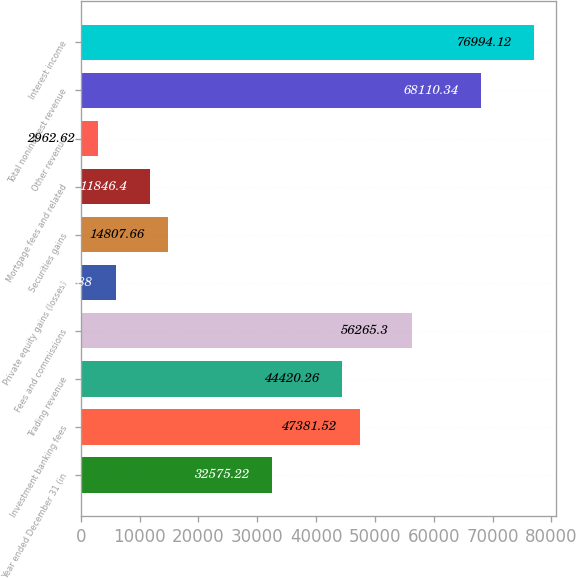Convert chart. <chart><loc_0><loc_0><loc_500><loc_500><bar_chart><fcel>Year ended December 31 (in<fcel>Investment banking fees<fcel>Trading revenue<fcel>Fees and commissions<fcel>Private equity gains (losses)<fcel>Securities gains<fcel>Mortgage fees and related<fcel>Other revenue<fcel>Total noninterest revenue<fcel>Interest income<nl><fcel>32575.2<fcel>47381.5<fcel>44420.3<fcel>56265.3<fcel>5923.88<fcel>14807.7<fcel>11846.4<fcel>2962.62<fcel>68110.3<fcel>76994.1<nl></chart> 